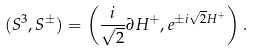Convert formula to latex. <formula><loc_0><loc_0><loc_500><loc_500>( S ^ { 3 } , S ^ { \pm } ) = \left ( \frac { i } { \sqrt { 2 } } \partial H ^ { + } , e ^ { \pm i \sqrt { 2 } H ^ { + } } \right ) .</formula> 